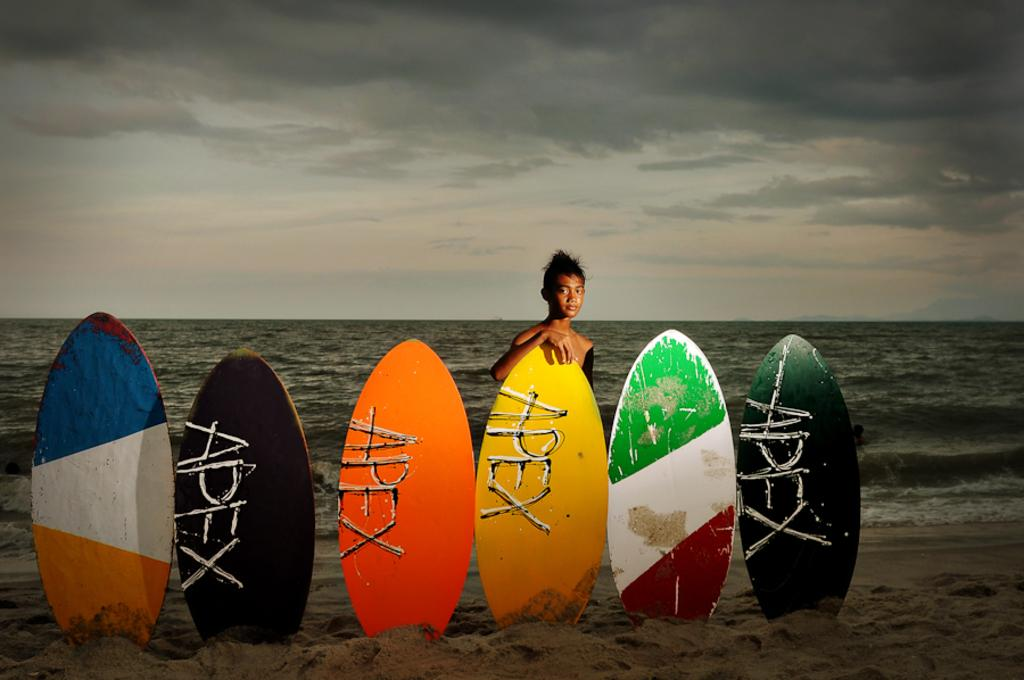What objects are in the sand in the image? There are surfboards in the sand in the image. Can you describe the person in the image? There is a person in the image. What body of water is visible in the image? There is an ocean visible in the image. What can be seen in the sky in the image? There are clouds in the sky in the image. What type of animal is being used as a skin for the surfboards in the image? There is no animal or skin present in the image; the surfboards are made of materials like fiberglass or foam. 